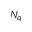Convert formula to latex. <formula><loc_0><loc_0><loc_500><loc_500>N _ { q }</formula> 